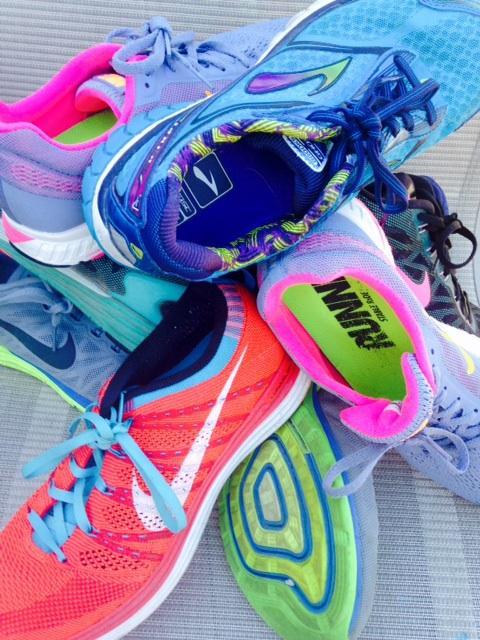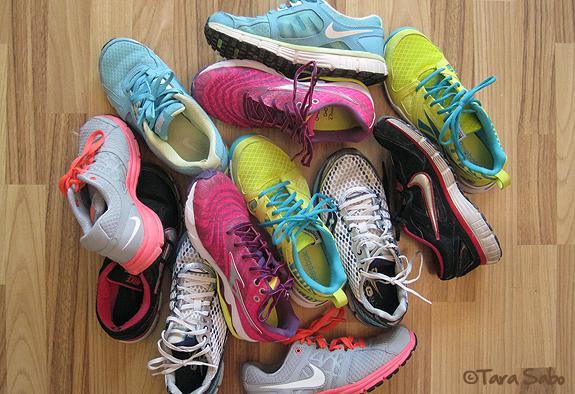The first image is the image on the left, the second image is the image on the right. Examine the images to the left and right. Is the description "In one image only the tops and sides of the shoes are visible." accurate? Answer yes or no. Yes. The first image is the image on the left, the second image is the image on the right. Evaluate the accuracy of this statement regarding the images: "At least one of the images prominently displays one or more Nike brand shoe with the brand's signature """"swoosh"""" logo on the side.". Is it true? Answer yes or no. Yes. 